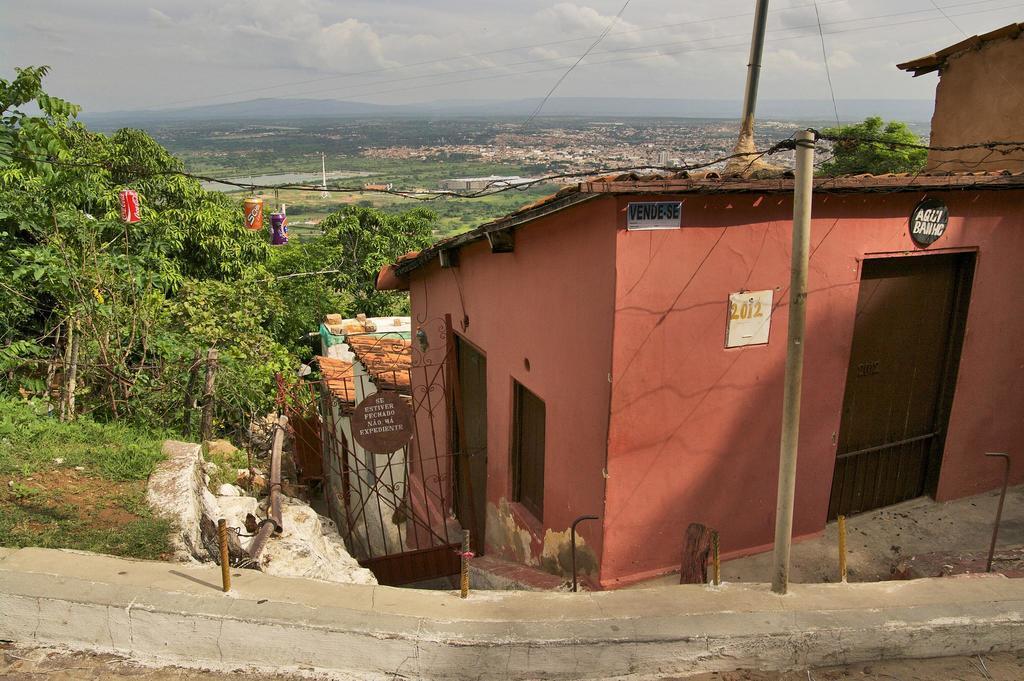In one or two sentences, can you explain what this image depicts? In this image I can see red color house and red color gate and I can see trees and pole and rope ,at the top I can see the sky and power line cables and I can see grass and at the bottom I can see the wall. 